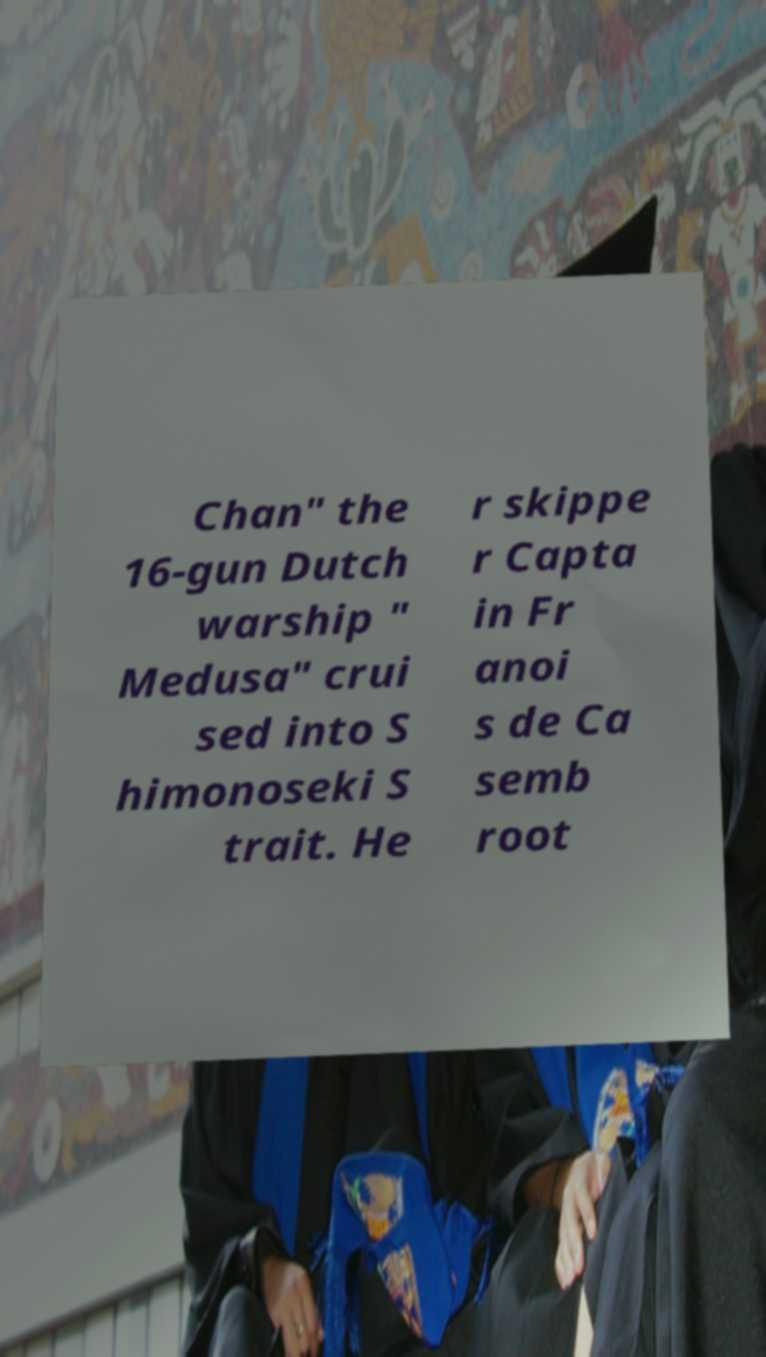Can you read and provide the text displayed in the image?This photo seems to have some interesting text. Can you extract and type it out for me? Chan" the 16-gun Dutch warship " Medusa" crui sed into S himonoseki S trait. He r skippe r Capta in Fr anoi s de Ca semb root 